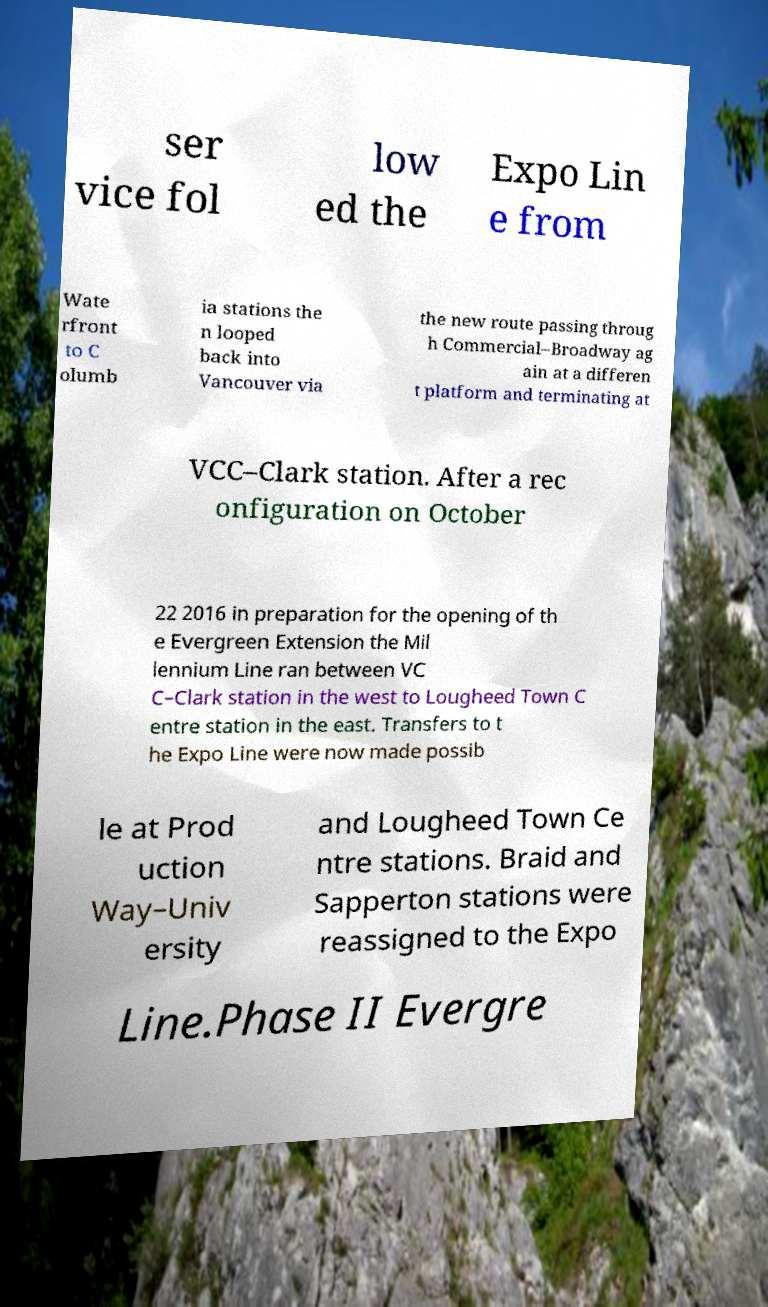I need the written content from this picture converted into text. Can you do that? ser vice fol low ed the Expo Lin e from Wate rfront to C olumb ia stations the n looped back into Vancouver via the new route passing throug h Commercial–Broadway ag ain at a differen t platform and terminating at VCC–Clark station. After a rec onfiguration on October 22 2016 in preparation for the opening of th e Evergreen Extension the Mil lennium Line ran between VC C–Clark station in the west to Lougheed Town C entre station in the east. Transfers to t he Expo Line were now made possib le at Prod uction Way–Univ ersity and Lougheed Town Ce ntre stations. Braid and Sapperton stations were reassigned to the Expo Line.Phase II Evergre 